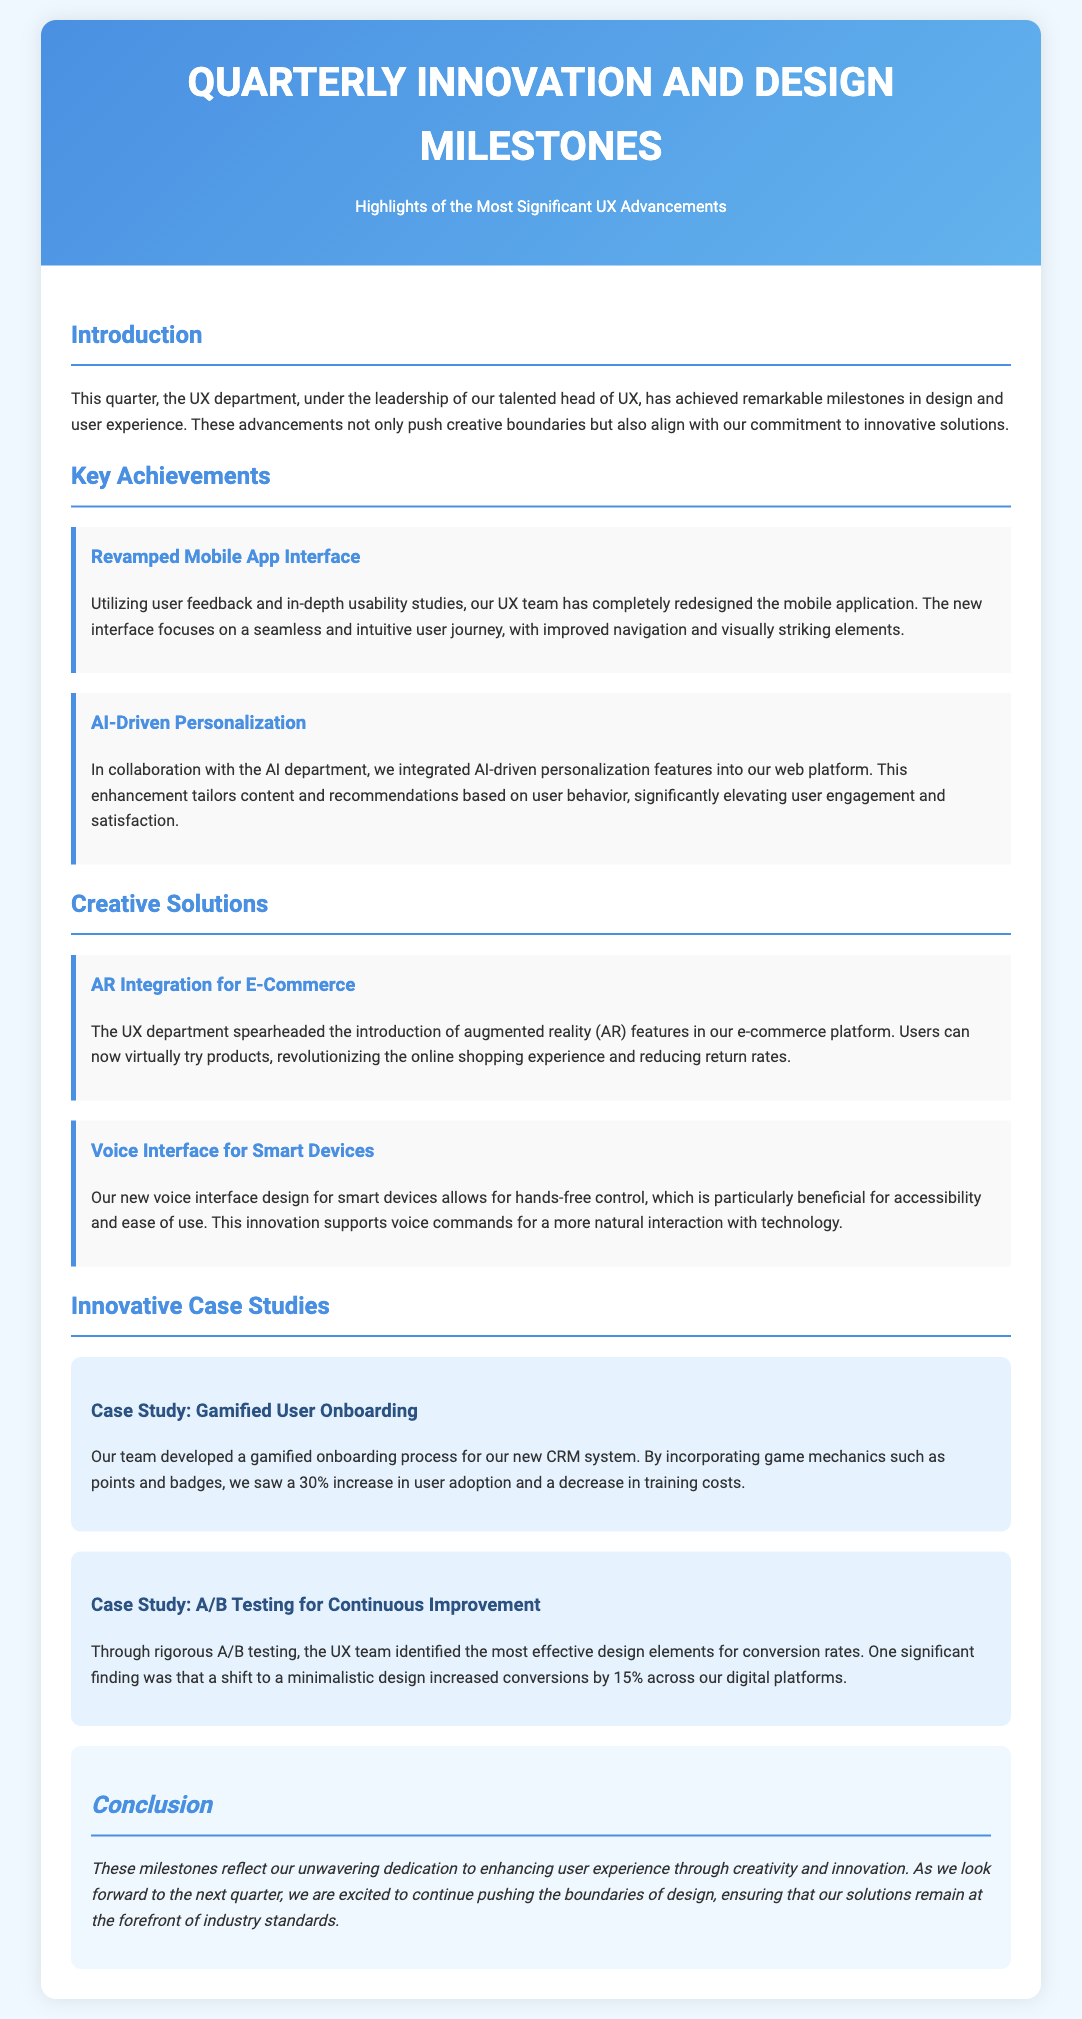What is the title of the document? The title appears in the header section, highlighting the main focus of the document.
Answer: Quarterly Innovation and Design Milestones What innovative feature was integrated into the web platform? The document specifies the collaborative efforts between the UX and AI departments, detailing a major advancement.
Answer: AI-driven personalization What was the percentage increase in user adoption due to the gamified onboarding process? The case study section provides specific metrics that indicate the effectiveness of the new onboarding approach.
Answer: 30% What technology was introduced in the e-commerce platform? The document describes a significant addition in the shopping experience related to new technology.
Answer: Augmented reality What design element significantly increased conversions by 15%? The A/B testing results indicate a specific design strategy that led to improved conversion rates.
Answer: Minimalistic design What is the color scheme used in the header section? The gradient colors mentioned help visualize the aesthetics of the header and overall presentation style.
Answer: Blue gradient How does the new voice interface improve user interaction? The document outlines the primary benefit of the new feature in terms of user accessibility and functionality.
Answer: Hands-free control What was a key focus of the mobile app redesign? The UX team prioritized specific aspects during the redevelopment of the mobile application stated in the achievements.
Answer: Seamless and intuitive user journey 